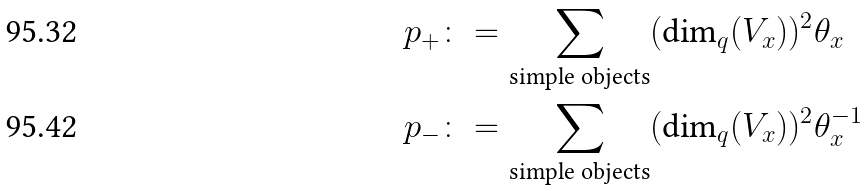<formula> <loc_0><loc_0><loc_500><loc_500>p _ { + } & \colon = \sum _ { \text {simple objects} } ( \text {dim} _ { q } ( V _ { x } ) ) ^ { 2 } \theta _ { x } \\ p _ { - } & \colon = \sum _ { \text {simple objects} } ( \text {dim} _ { q } ( V _ { x } ) ) ^ { 2 } \theta ^ { - 1 } _ { x }</formula> 